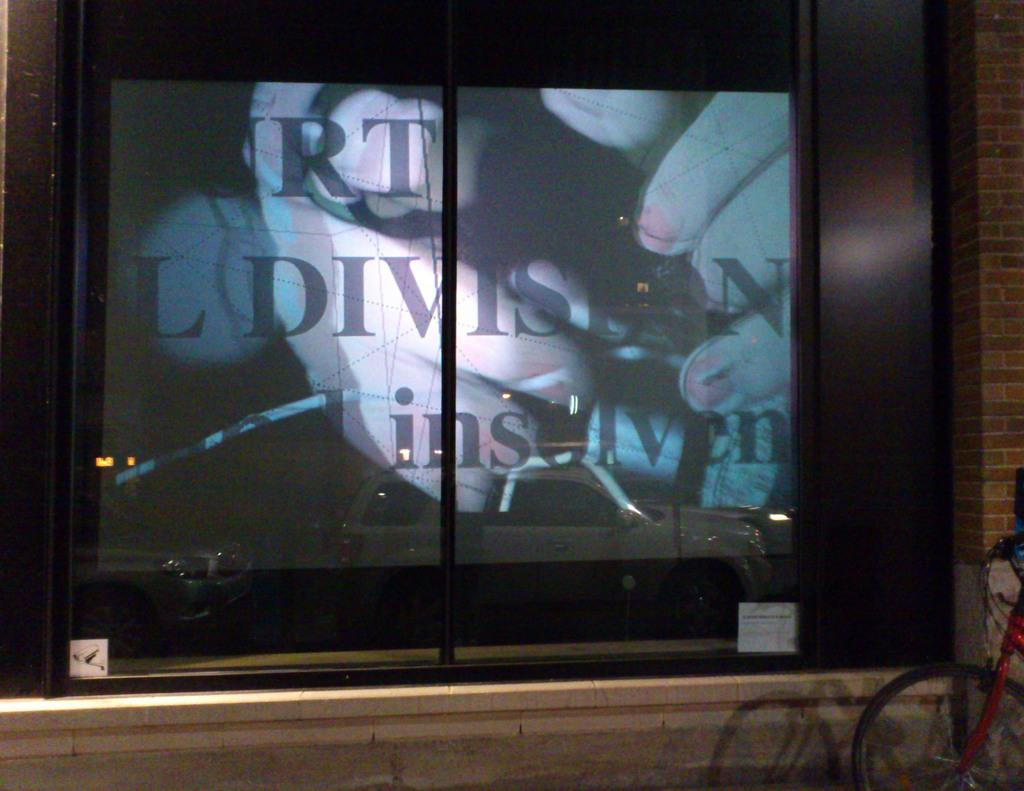What is the main object in the image? There is a television screen in the image. Where is the man located in the image? The man is standing near a brick wall on the right side of the image. What is the man standing beside? There is a bicycle beside the man in the image. What type of patch is sewn onto the man's shirt in the image? There is no patch visible on the man's shirt in the image. What ornament is hanging from the bicycle in the image? There is no ornament hanging from the bicycle in the image. 